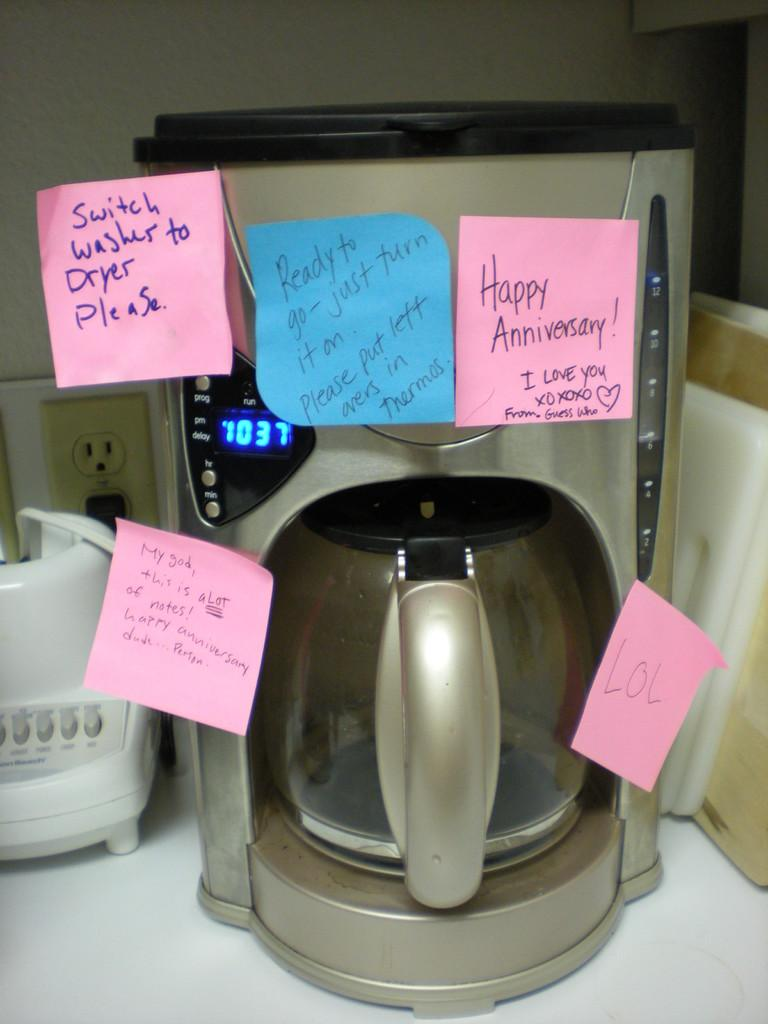<image>
Give a short and clear explanation of the subsequent image. A coffee pot covered in Post It notes, one of which says Happy Anniversary. 